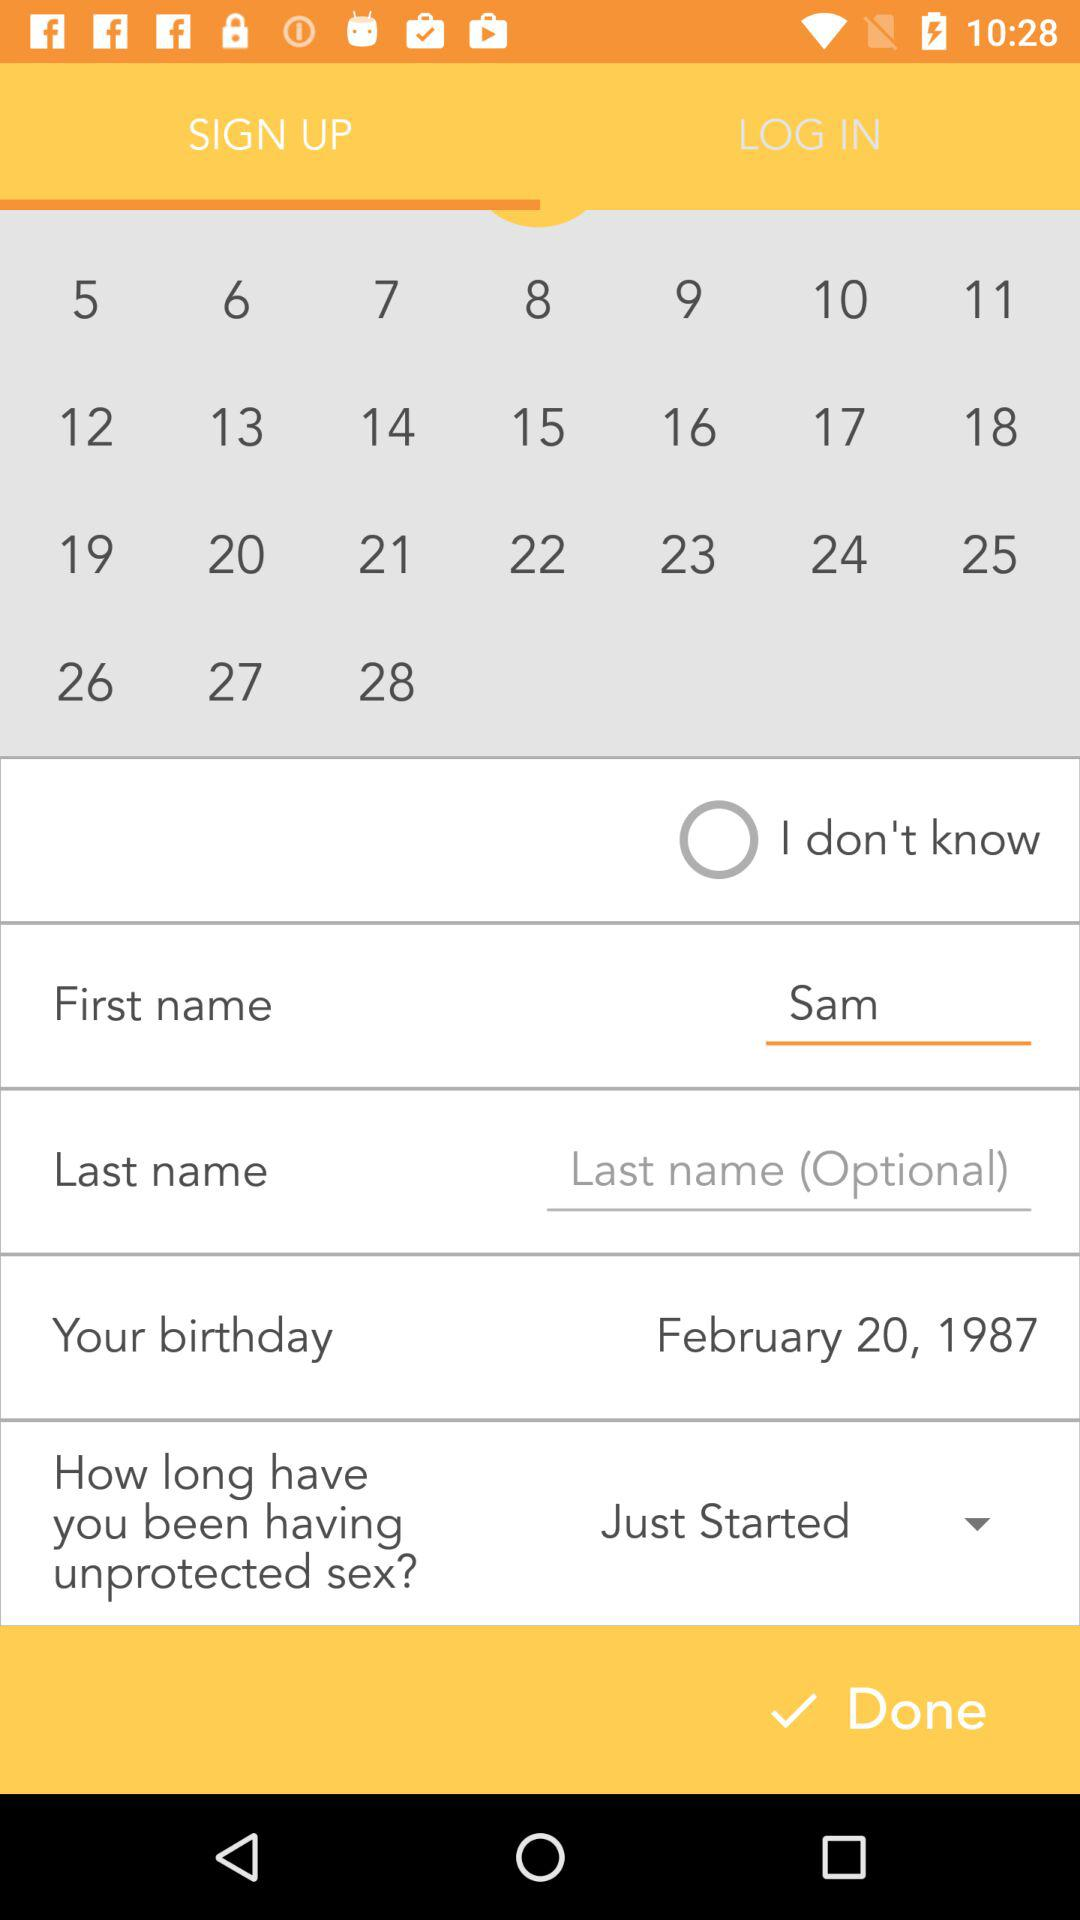What is the birthdate? The birthdate is February 20, 1987. 